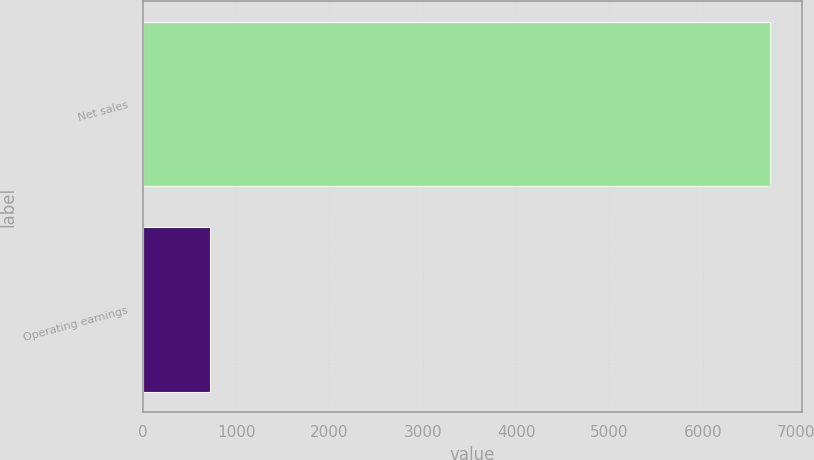Convert chart to OTSL. <chart><loc_0><loc_0><loc_500><loc_500><bar_chart><fcel>Net sales<fcel>Operating earnings<nl><fcel>6722<fcel>718<nl></chart> 